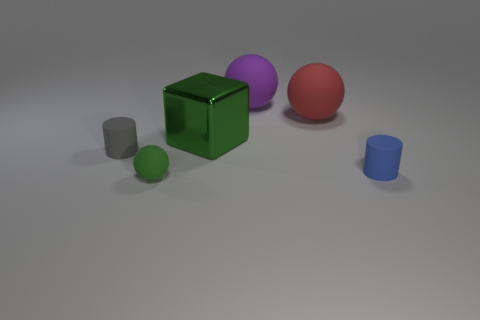Is there a gray matte object of the same size as the green rubber object?
Your response must be concise. Yes. What number of gray matte cylinders are there?
Offer a very short reply. 1. What number of big objects are either spheres or green balls?
Offer a very short reply. 2. There is a small rubber cylinder to the left of the green thing behind the tiny cylinder on the left side of the big green thing; what is its color?
Provide a short and direct response. Gray. How many matte things are either tiny balls or green objects?
Offer a terse response. 1. There is a thing that is behind the big red matte sphere; is its color the same as the rubber object that is to the right of the big red rubber sphere?
Your answer should be very brief. No. Is there anything else that is made of the same material as the green cube?
Your response must be concise. No. What size is the red matte object that is the same shape as the tiny green object?
Give a very brief answer. Large. Is the number of green spheres that are in front of the green matte ball greater than the number of green matte spheres?
Keep it short and to the point. No. Does the sphere that is in front of the gray matte object have the same material as the tiny blue cylinder?
Provide a succinct answer. Yes. 